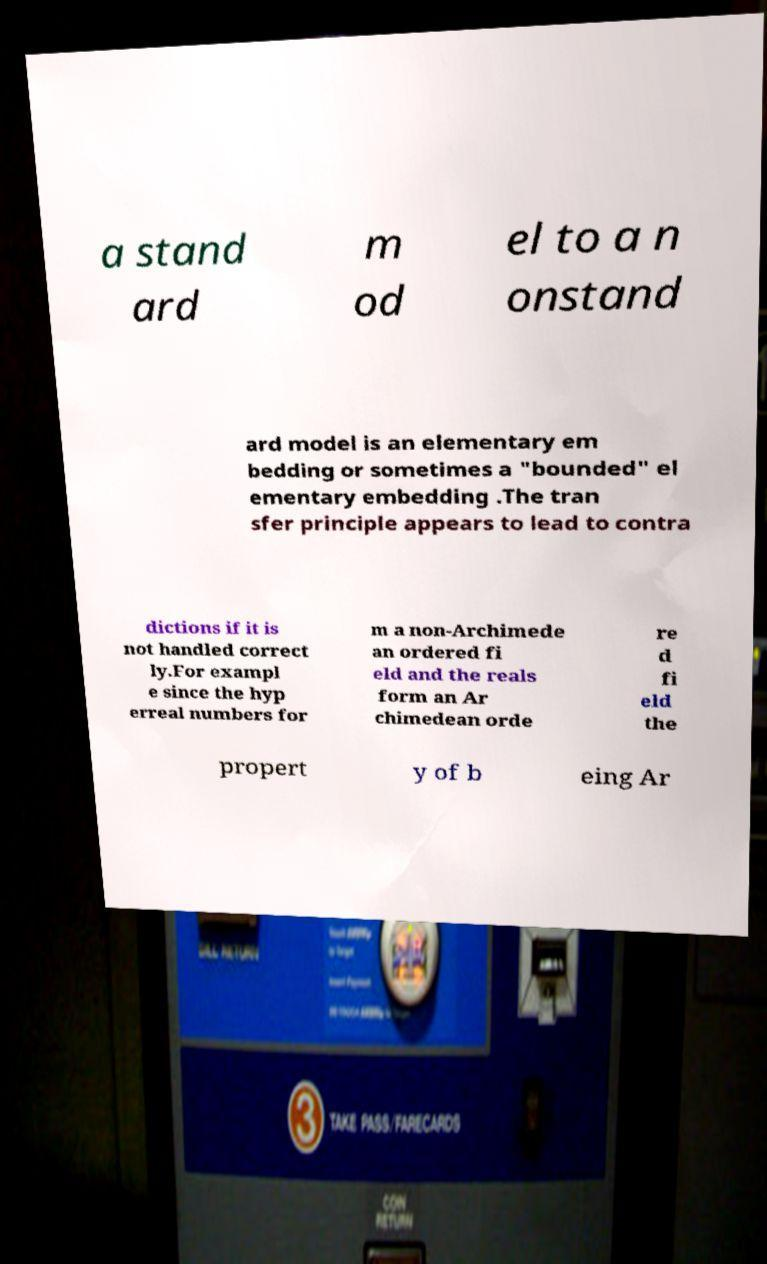Can you read and provide the text displayed in the image?This photo seems to have some interesting text. Can you extract and type it out for me? a stand ard m od el to a n onstand ard model is an elementary em bedding or sometimes a "bounded" el ementary embedding .The tran sfer principle appears to lead to contra dictions if it is not handled correct ly.For exampl e since the hyp erreal numbers for m a non-Archimede an ordered fi eld and the reals form an Ar chimedean orde re d fi eld the propert y of b eing Ar 